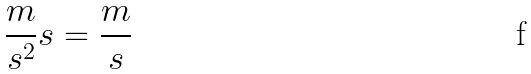Convert formula to latex. <formula><loc_0><loc_0><loc_500><loc_500>\frac { m } { s ^ { 2 } } s = \frac { m } { s }</formula> 